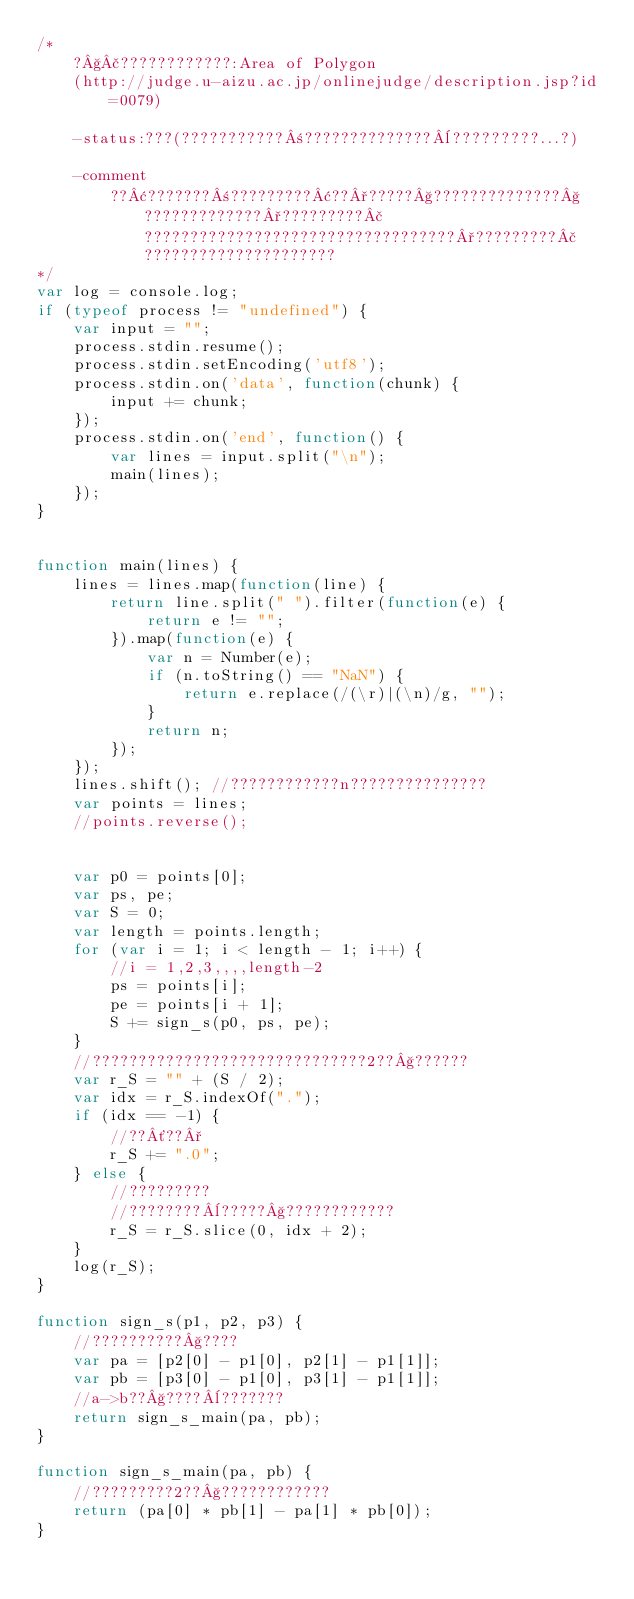Convert code to text. <code><loc_0><loc_0><loc_500><loc_500><_JavaScript_>/*
	?§£????????????:Area of Polygon
	(http://judge.u-aizu.ac.jp/onlinejudge/description.jsp?id=0079)

	-status:???(???????????±??????????????¨?????????...?)

	-comment
        ??¢???????±?????????¢??°?????§??????????????§?????????????°?????????£??????????????????????????????????°?????????£?????????????????????
*/
var log = console.log;
if (typeof process != "undefined") {
    var input = "";
    process.stdin.resume();
    process.stdin.setEncoding('utf8');
    process.stdin.on('data', function(chunk) {
        input += chunk;
    });
    process.stdin.on('end', function() {
        var lines = input.split("\n");
        main(lines);
    });
}


function main(lines) {
    lines = lines.map(function(line) {
        return line.split(" ").filter(function(e) {
            return e != "";
        }).map(function(e) {
            var n = Number(e);
            if (n.toString() == "NaN") {
                return e.replace(/(\r)|(\n)/g, "");
            }
            return n;
        });
    });
    lines.shift(); //????????????n???????????????
    var points = lines;
    //points.reverse();


    var p0 = points[0];
    var ps, pe;
    var S = 0;
    var length = points.length;
    for (var i = 1; i < length - 1; i++) {
        //i = 1,2,3,,,,length-2
        ps = points[i];
        pe = points[i + 1];
        S += sign_s(p0, ps, pe);
    }
    //??????????????????????????????2??§??????
    var r_S = "" + (S / 2);
    var idx = r_S.indexOf(".");
    if (idx == -1) {
        //??´??°
        r_S += ".0";
    } else {
        //?????????
        //????????¨?????§????????????
        r_S = r_S.slice(0, idx + 2);
    }
    log(r_S);
}

function sign_s(p1, p2, p3) {
    //??????????§????
    var pa = [p2[0] - p1[0], p2[1] - p1[1]];
    var pb = [p3[0] - p1[0], p3[1] - p1[1]];
    //a->b??§????¨???????
    return sign_s_main(pa, pb);
}

function sign_s_main(pa, pb) {
    //?????????2??§????????????
    return (pa[0] * pb[1] - pa[1] * pb[0]);
}</code> 